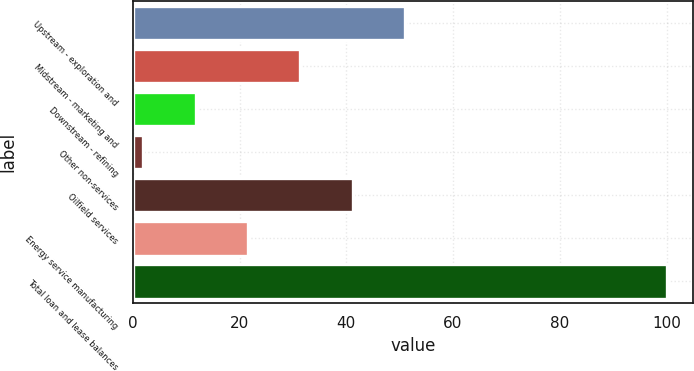Convert chart. <chart><loc_0><loc_0><loc_500><loc_500><bar_chart><fcel>Upstream - exploration and<fcel>Midstream - marketing and<fcel>Downstream - refining<fcel>Other non-services<fcel>Oilfield services<fcel>Energy service manufacturing<fcel>Total loan and lease balances<nl><fcel>51<fcel>31.4<fcel>11.8<fcel>2<fcel>41.2<fcel>21.6<fcel>100<nl></chart> 